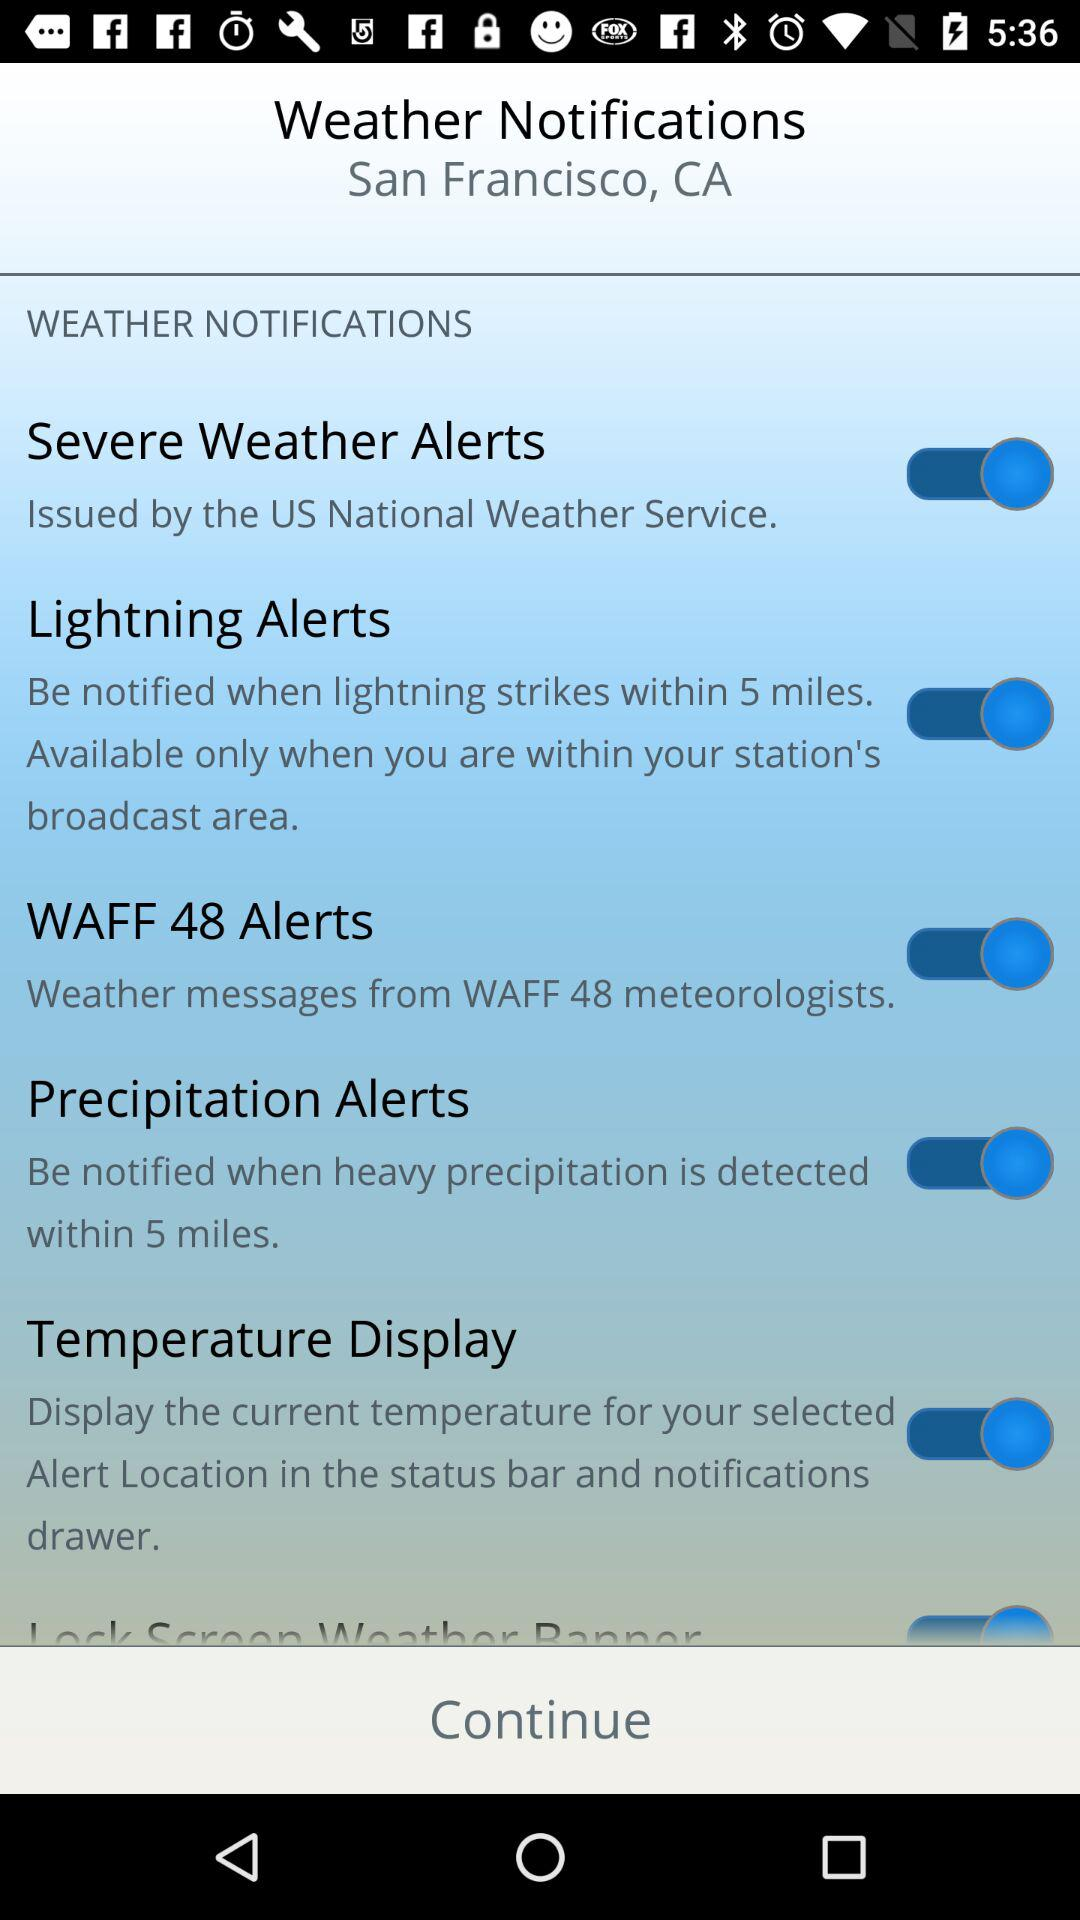How many types of alerts are available?
Answer the question using a single word or phrase. 6 